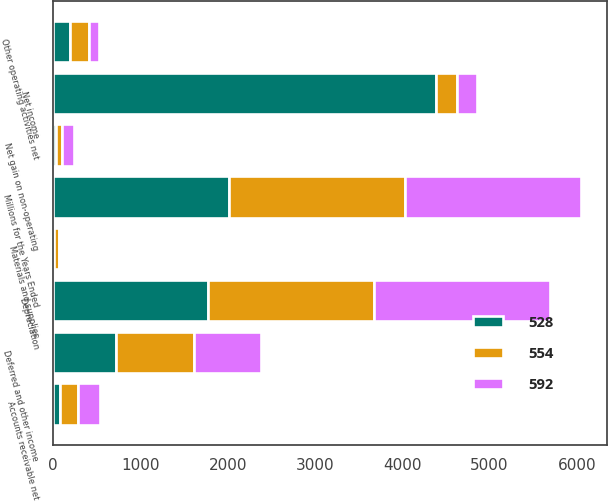Convert chart. <chart><loc_0><loc_0><loc_500><loc_500><stacked_bar_chart><ecel><fcel>Millions for the Years Ended<fcel>Net income<fcel>Depreciation<fcel>Deferred and other income<fcel>Net gain on non-operating<fcel>Other operating activities net<fcel>Accounts receivable net<fcel>Materials and supplies<nl><fcel>592<fcel>2015<fcel>235.5<fcel>2012<fcel>765<fcel>144<fcel>116<fcel>255<fcel>24<nl><fcel>554<fcel>2014<fcel>235.5<fcel>1904<fcel>895<fcel>69<fcel>216<fcel>197<fcel>59<nl><fcel>528<fcel>2013<fcel>4388<fcel>1777<fcel>723<fcel>32<fcel>194<fcel>83<fcel>7<nl></chart> 